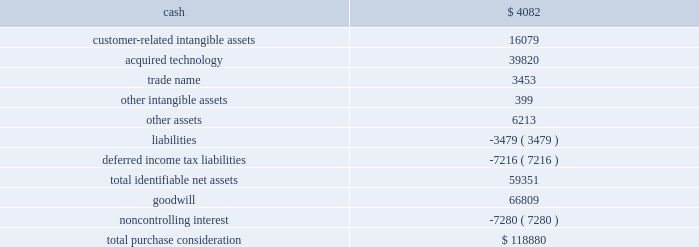Acquisition date ) .
Realex is a leading european online payment gateway technology provider .
This acquisition furthered our strategy to provide omnichannel solutions that combine gateway services , payment service provisioning and payment technology services across europe .
This transaction was accounted for as a business combination .
We recorded the assets acquired , liabilities assumed and noncontrolling interest at their estimated fair values as of the acquisition date .
On october 5 , 2015 , we paid 20ac6.7 million ( $ 7.5 million equivalent as of october 5 , 2015 ) to acquire the remaining shares of realex , after which we own 100% ( 100 % ) of the outstanding shares .
The estimated acquisition date fair values of the assets acquired , liabilities assumed and the noncontrolling interest , including a reconciliation to the total purchase consideration , are as follows ( in thousands ) : .
Goodwill of $ 66.8 million arising from the acquisition , included in the europe segment , was attributable to expected growth opportunities in europe , potential synergies from combining our existing business with gateway services and payment service provisioning in certain markets and an assembled workforce to support the newly acquired technology .
Goodwill associated with this acquisition is not deductible for income tax purposes .
The customer-related intangible assets have an estimated amortization period of 16 years .
The acquired technology has an estimated amortization of 10 years .
The trade name has an estimated amortization period of 7 years .
Ezidebit on october 10 , 2014 , we completed the acquisition of 100% ( 100 % ) of the outstanding stock of ezi holdings pty ltd ( 201cezidebit 201d ) for aud302.6 million in cash ( $ 266.0 million equivalent as of the acquisition date ) .
This acquisition was funded by a combination of cash on hand and borrowings on our revolving credit facility .
Ezidebit is a leading integrated payments company focused on recurring payments verticals in australia and new zealand .
The acquisition of ezidebit further enhanced our existing integrated solutions offerings .
This transaction was accounted for as a business combination .
We recorded the assets acquired and liabilities assumed at their estimated fair values as of the acquisition date .
76 2013 global payments inc .
| 2017 form 10-k annual report .
What percentage of the total purchase consideration did goodwill represent? 
Computations: (66809 / 118880)
Answer: 0.56199. 